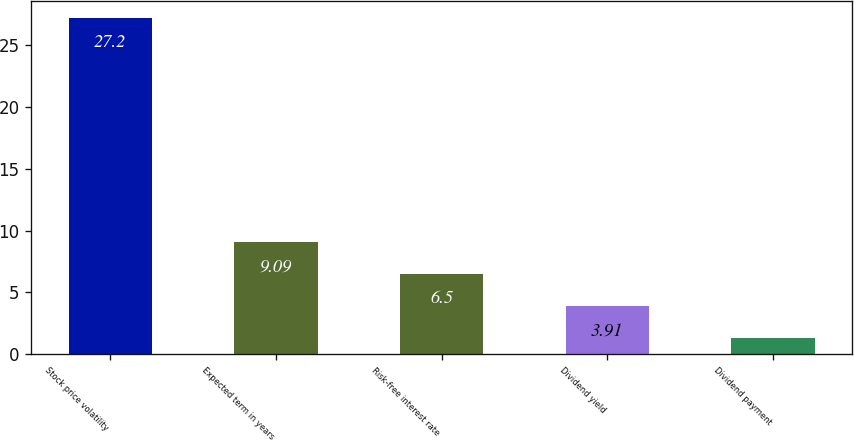Convert chart. <chart><loc_0><loc_0><loc_500><loc_500><bar_chart><fcel>Stock price volatility<fcel>Expected term in years<fcel>Risk-free interest rate<fcel>Dividend yield<fcel>Dividend payment<nl><fcel>27.2<fcel>9.09<fcel>6.5<fcel>3.91<fcel>1.32<nl></chart> 